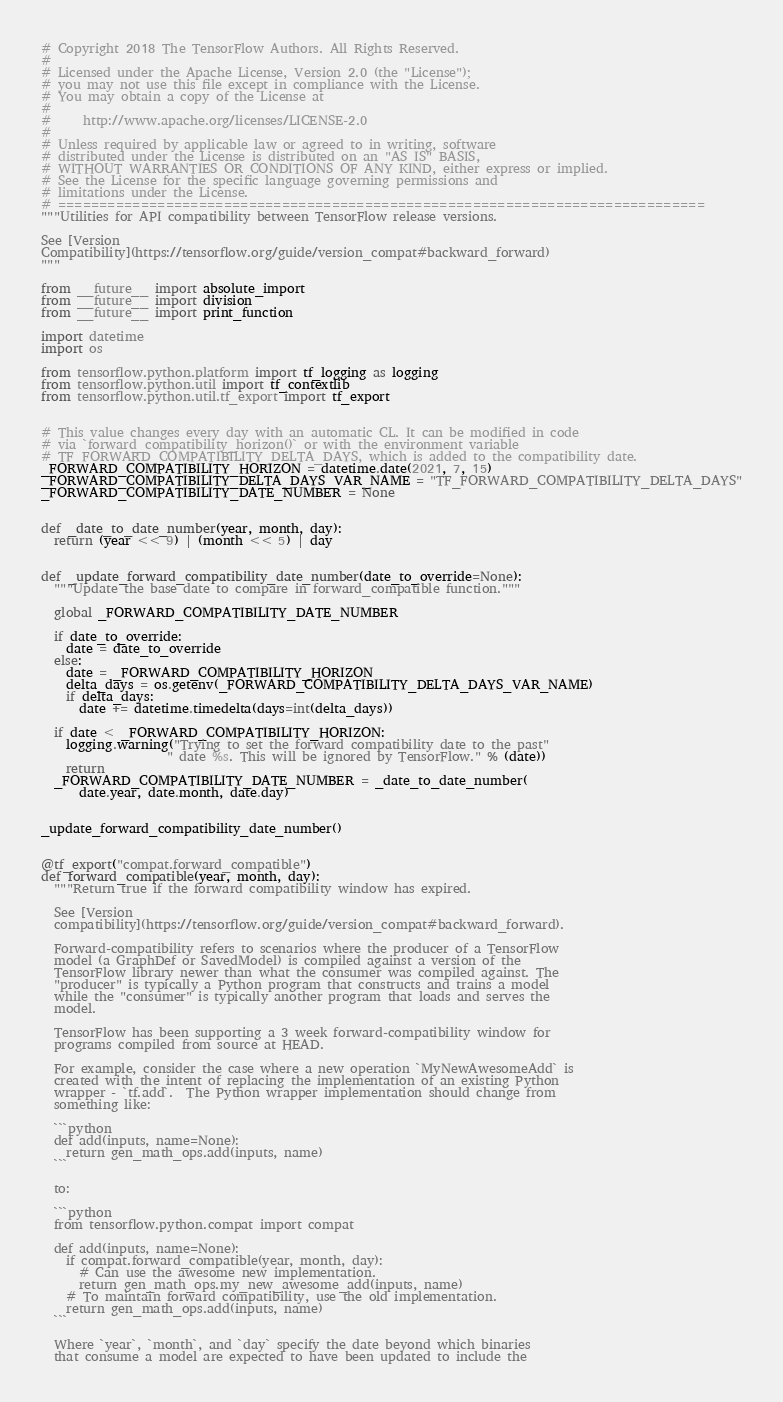<code> <loc_0><loc_0><loc_500><loc_500><_Python_># Copyright 2018 The TensorFlow Authors. All Rights Reserved.
#
# Licensed under the Apache License, Version 2.0 (the "License");
# you may not use this file except in compliance with the License.
# You may obtain a copy of the License at
#
#     http://www.apache.org/licenses/LICENSE-2.0
#
# Unless required by applicable law or agreed to in writing, software
# distributed under the License is distributed on an "AS IS" BASIS,
# WITHOUT WARRANTIES OR CONDITIONS OF ANY KIND, either express or implied.
# See the License for the specific language governing permissions and
# limitations under the License.
# ==============================================================================
"""Utilities for API compatibility between TensorFlow release versions.

See [Version
Compatibility](https://tensorflow.org/guide/version_compat#backward_forward)
"""

from __future__ import absolute_import
from __future__ import division
from __future__ import print_function

import datetime
import os

from tensorflow.python.platform import tf_logging as logging
from tensorflow.python.util import tf_contextlib
from tensorflow.python.util.tf_export import tf_export


# This value changes every day with an automatic CL. It can be modified in code
# via `forward_compatibility_horizon()` or with the environment variable
# TF_FORWARD_COMPATIBILITY_DELTA_DAYS, which is added to the compatibility date.
_FORWARD_COMPATIBILITY_HORIZON = datetime.date(2021, 7, 15)
_FORWARD_COMPATIBILITY_DELTA_DAYS_VAR_NAME = "TF_FORWARD_COMPATIBILITY_DELTA_DAYS"
_FORWARD_COMPATIBILITY_DATE_NUMBER = None


def _date_to_date_number(year, month, day):
  return (year << 9) | (month << 5) | day


def _update_forward_compatibility_date_number(date_to_override=None):
  """Update the base date to compare in forward_compatible function."""

  global _FORWARD_COMPATIBILITY_DATE_NUMBER

  if date_to_override:
    date = date_to_override
  else:
    date = _FORWARD_COMPATIBILITY_HORIZON
    delta_days = os.getenv(_FORWARD_COMPATIBILITY_DELTA_DAYS_VAR_NAME)
    if delta_days:
      date += datetime.timedelta(days=int(delta_days))

  if date < _FORWARD_COMPATIBILITY_HORIZON:
    logging.warning("Trying to set the forward compatibility date to the past"
                    " date %s. This will be ignored by TensorFlow." % (date))
    return
  _FORWARD_COMPATIBILITY_DATE_NUMBER = _date_to_date_number(
      date.year, date.month, date.day)


_update_forward_compatibility_date_number()


@tf_export("compat.forward_compatible")
def forward_compatible(year, month, day):
  """Return true if the forward compatibility window has expired.

  See [Version
  compatibility](https://tensorflow.org/guide/version_compat#backward_forward).

  Forward-compatibility refers to scenarios where the producer of a TensorFlow
  model (a GraphDef or SavedModel) is compiled against a version of the
  TensorFlow library newer than what the consumer was compiled against. The
  "producer" is typically a Python program that constructs and trains a model
  while the "consumer" is typically another program that loads and serves the
  model.

  TensorFlow has been supporting a 3 week forward-compatibility window for
  programs compiled from source at HEAD.

  For example, consider the case where a new operation `MyNewAwesomeAdd` is
  created with the intent of replacing the implementation of an existing Python
  wrapper - `tf.add`.  The Python wrapper implementation should change from
  something like:

  ```python
  def add(inputs, name=None):
    return gen_math_ops.add(inputs, name)
  ```

  to:

  ```python
  from tensorflow.python.compat import compat

  def add(inputs, name=None):
    if compat.forward_compatible(year, month, day):
      # Can use the awesome new implementation.
      return gen_math_ops.my_new_awesome_add(inputs, name)
    # To maintain forward compatibility, use the old implementation.
    return gen_math_ops.add(inputs, name)
  ```

  Where `year`, `month`, and `day` specify the date beyond which binaries
  that consume a model are expected to have been updated to include the</code> 